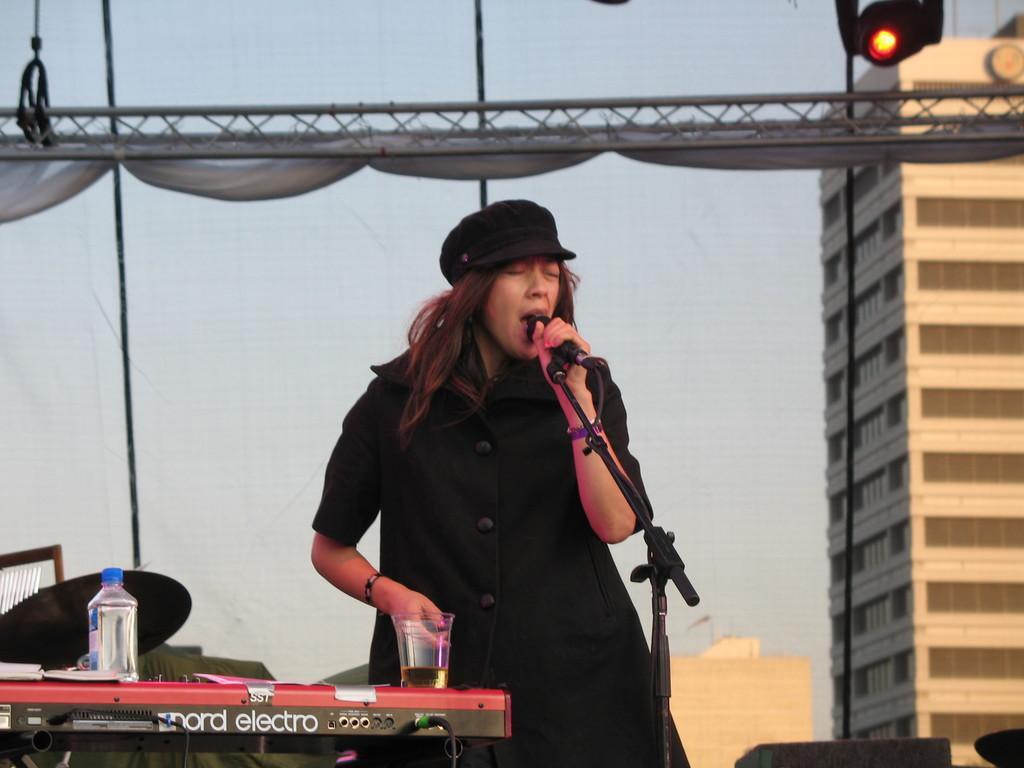Describe this image in one or two sentences. Here in the middle we can see a woman singing in the microphone present in front of her and beside her we can see another musical instrument having bottle of water and glass of beer present and and behind her we can see a building present 